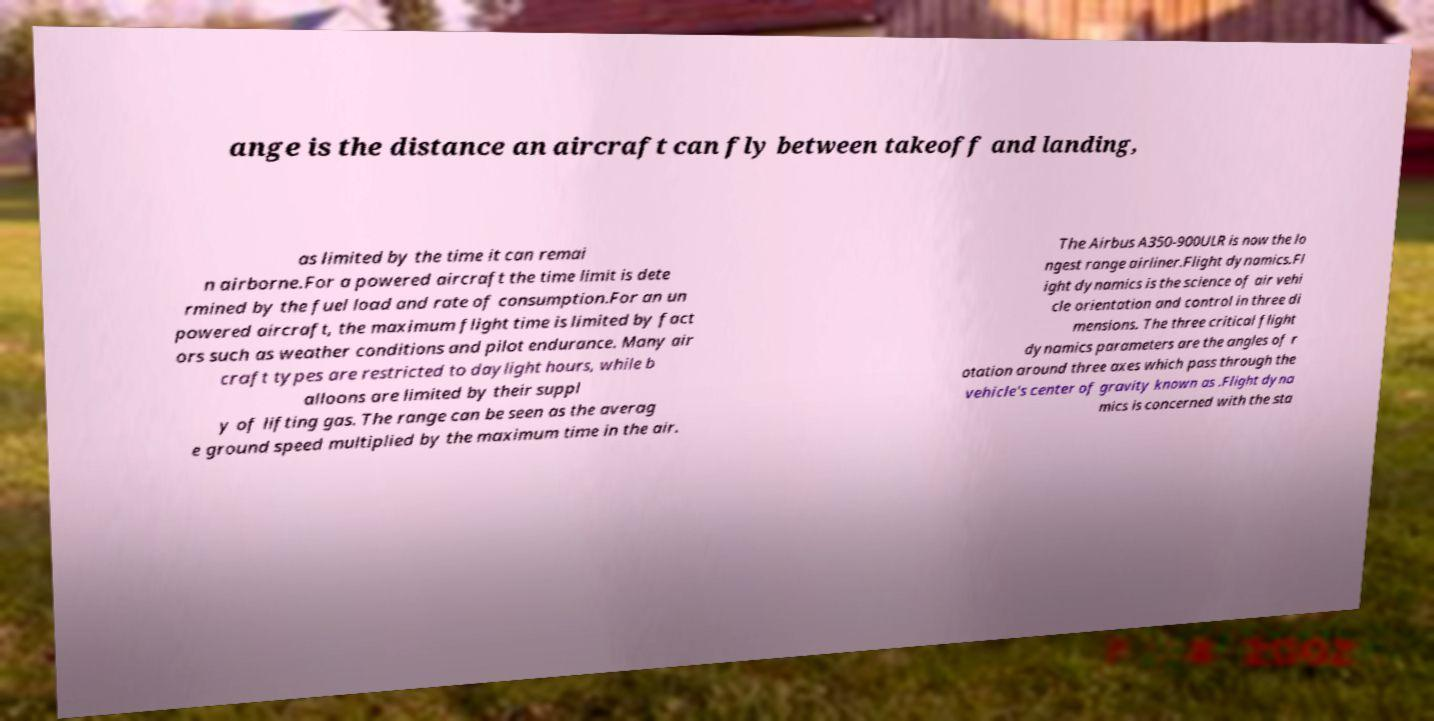I need the written content from this picture converted into text. Can you do that? ange is the distance an aircraft can fly between takeoff and landing, as limited by the time it can remai n airborne.For a powered aircraft the time limit is dete rmined by the fuel load and rate of consumption.For an un powered aircraft, the maximum flight time is limited by fact ors such as weather conditions and pilot endurance. Many air craft types are restricted to daylight hours, while b alloons are limited by their suppl y of lifting gas. The range can be seen as the averag e ground speed multiplied by the maximum time in the air. The Airbus A350-900ULR is now the lo ngest range airliner.Flight dynamics.Fl ight dynamics is the science of air vehi cle orientation and control in three di mensions. The three critical flight dynamics parameters are the angles of r otation around three axes which pass through the vehicle's center of gravity known as .Flight dyna mics is concerned with the sta 